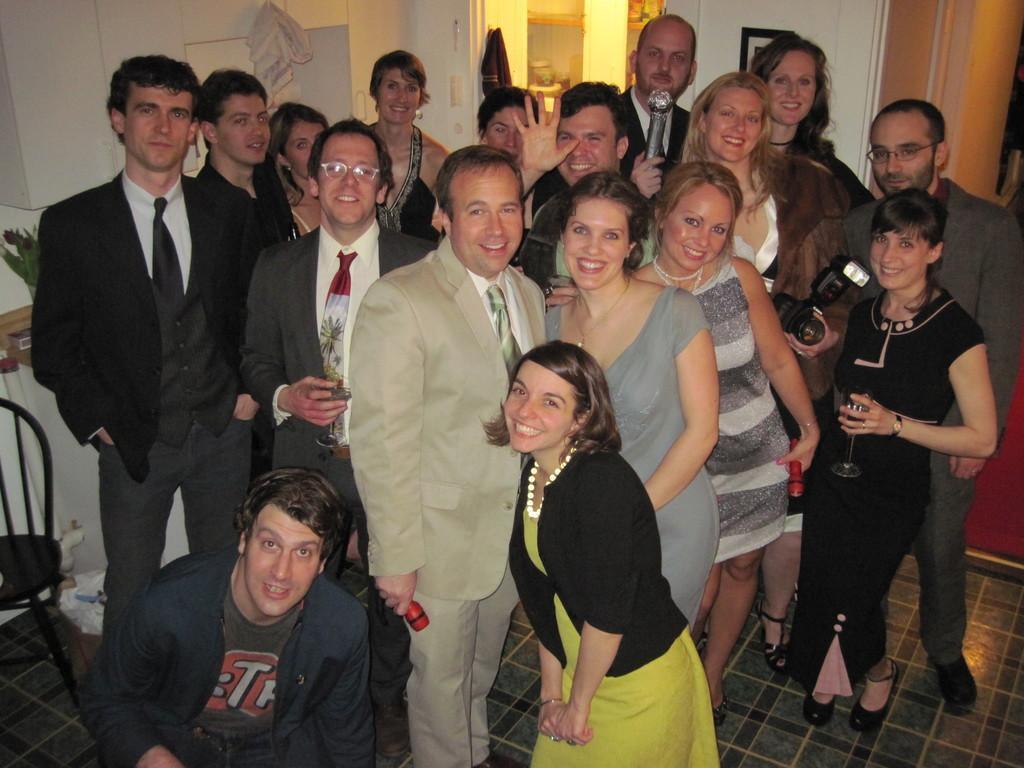In one or two sentences, can you explain what this image depicts? In the picture we can see a group of people standing on the floor and men are wearing a blazer, ties and shirts and with some women and to the floor, we can also see some chair and in the background we can see a wall with some photo frame and a light. 